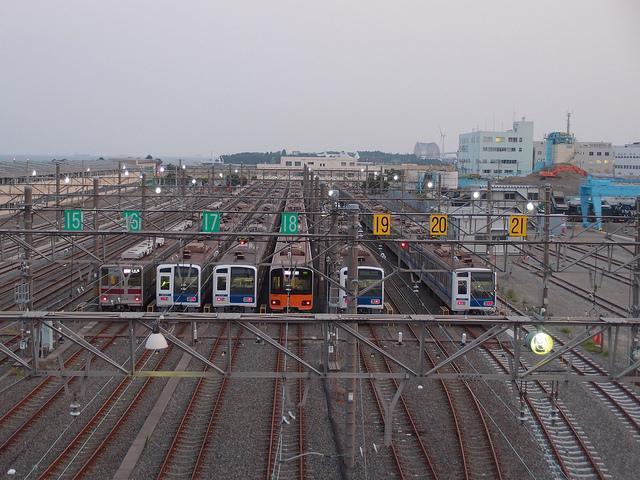How many trains are there?
Give a very brief answer. 5. How many people are in the water?
Give a very brief answer. 0. 